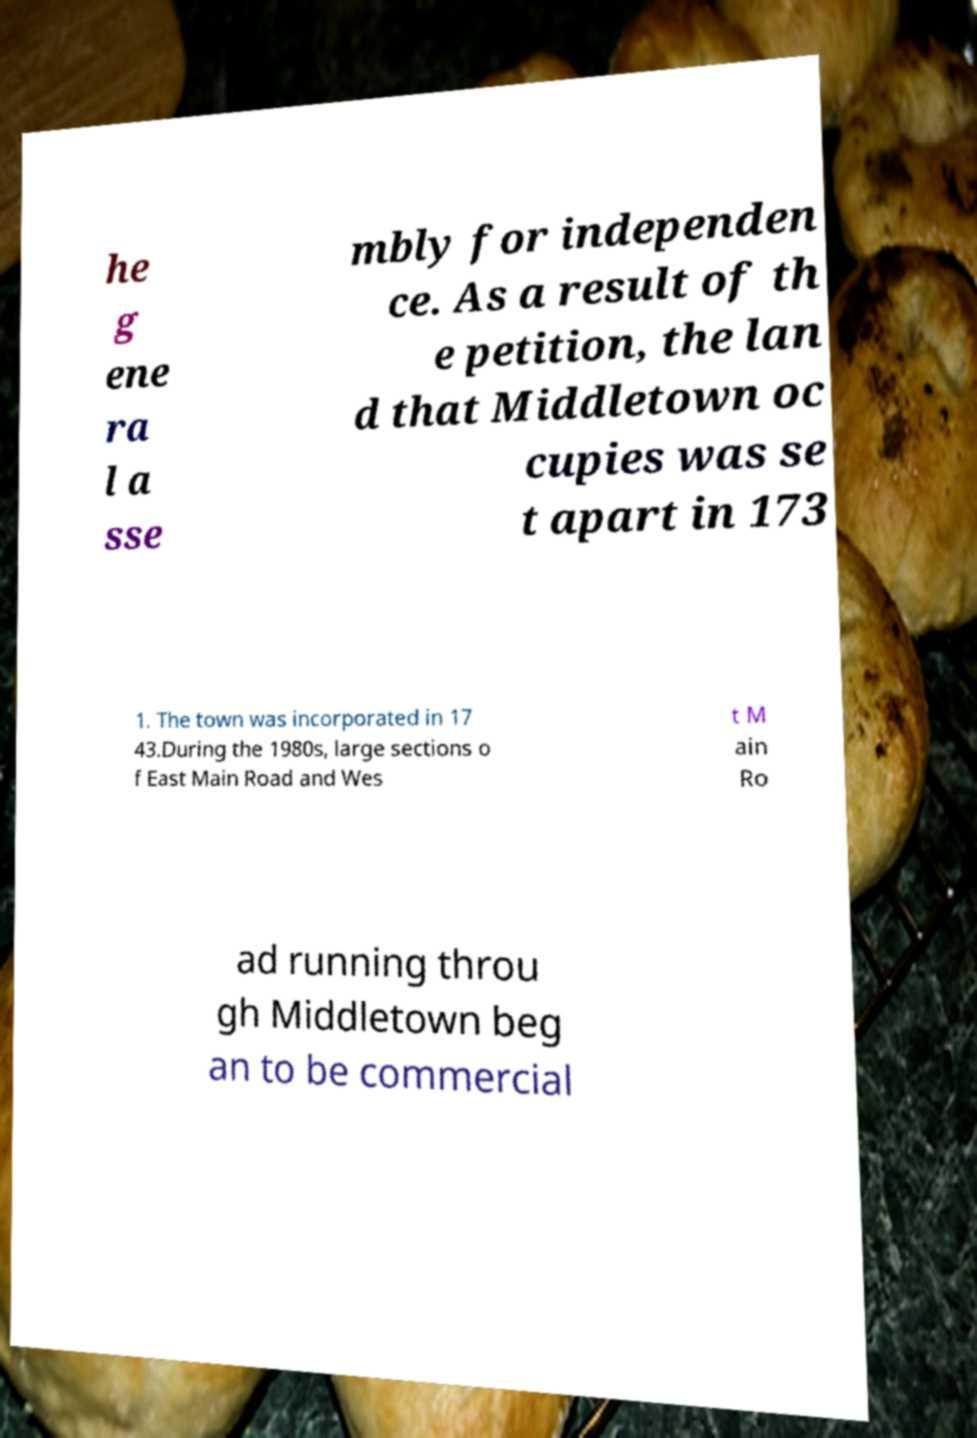Please read and relay the text visible in this image. What does it say? he g ene ra l a sse mbly for independen ce. As a result of th e petition, the lan d that Middletown oc cupies was se t apart in 173 1. The town was incorporated in 17 43.During the 1980s, large sections o f East Main Road and Wes t M ain Ro ad running throu gh Middletown beg an to be commercial 